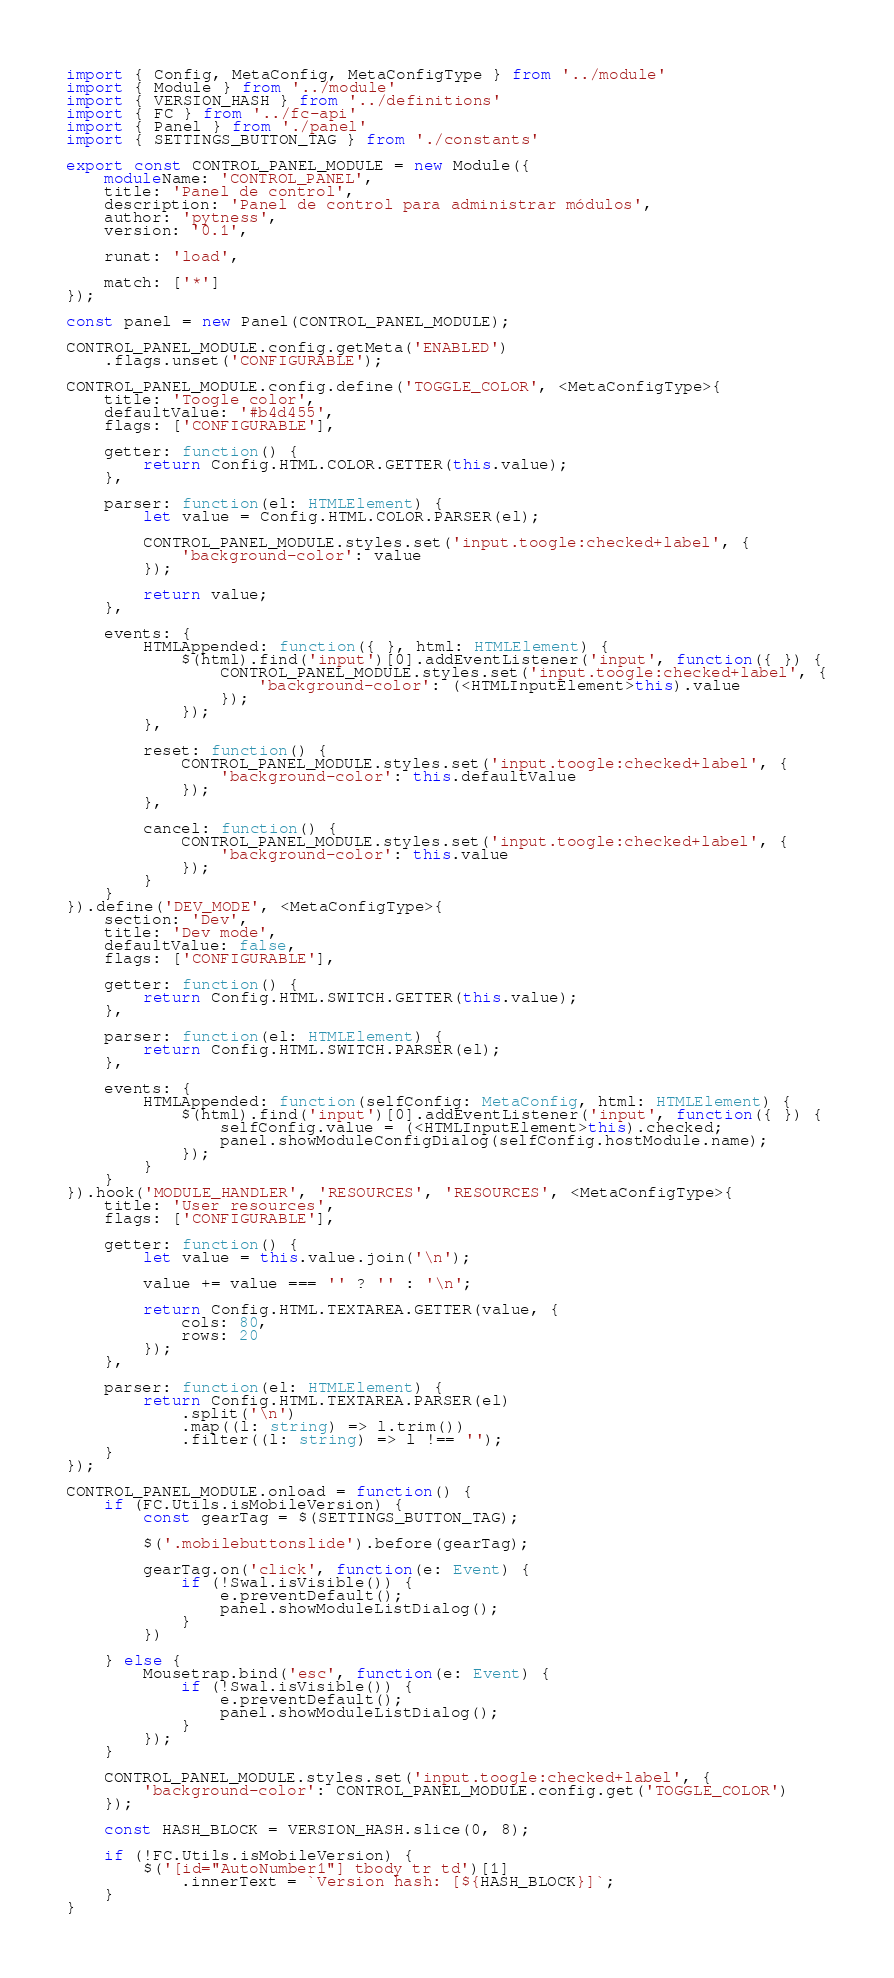Convert code to text. <code><loc_0><loc_0><loc_500><loc_500><_TypeScript_>import { Config, MetaConfig, MetaConfigType } from '../module'
import { Module } from '../module'
import { VERSION_HASH } from '../definitions'
import { FC } from '../fc-api'
import { Panel } from './panel'
import { SETTINGS_BUTTON_TAG } from './constants'

export const CONTROL_PANEL_MODULE = new Module({
	moduleName: 'CONTROL_PANEL',
	title: 'Panel de control',
	description: 'Panel de control para administrar módulos',
	author: 'pytness',
	version: '0.1',

	runat: 'load',

	match: ['*']
});

const panel = new Panel(CONTROL_PANEL_MODULE);

CONTROL_PANEL_MODULE.config.getMeta('ENABLED')
	.flags.unset('CONFIGURABLE');

CONTROL_PANEL_MODULE.config.define('TOGGLE_COLOR', <MetaConfigType>{
	title: 'Toogle color',
	defaultValue: '#b4d455',
	flags: ['CONFIGURABLE'],

	getter: function() {
		return Config.HTML.COLOR.GETTER(this.value);
	},

	parser: function(el: HTMLElement) {
		let value = Config.HTML.COLOR.PARSER(el);

		CONTROL_PANEL_MODULE.styles.set('input.toogle:checked+label', {
			'background-color': value
		});

		return value;
	},

	events: {
		HTMLAppended: function({ }, html: HTMLElement) {
			$(html).find('input')[0].addEventListener('input', function({ }) {
				CONTROL_PANEL_MODULE.styles.set('input.toogle:checked+label', {
					'background-color': (<HTMLInputElement>this).value
				});
			});
		},

		reset: function() {
			CONTROL_PANEL_MODULE.styles.set('input.toogle:checked+label', {
				'background-color': this.defaultValue
			});
		},

		cancel: function() {
			CONTROL_PANEL_MODULE.styles.set('input.toogle:checked+label', {
				'background-color': this.value
			});
		}
	}
}).define('DEV_MODE', <MetaConfigType>{
	section: 'Dev',
	title: 'Dev mode',
	defaultValue: false,
	flags: ['CONFIGURABLE'],

	getter: function() {
		return Config.HTML.SWITCH.GETTER(this.value);
	},

	parser: function(el: HTMLElement) {
		return Config.HTML.SWITCH.PARSER(el);
	},

	events: {
		HTMLAppended: function(selfConfig: MetaConfig, html: HTMLElement) {
			$(html).find('input')[0].addEventListener('input', function({ }) {
				selfConfig.value = (<HTMLInputElement>this).checked;
				panel.showModuleConfigDialog(selfConfig.hostModule.name);
			});
		}
	}
}).hook('MODULE_HANDLER', 'RESOURCES', 'RESOURCES', <MetaConfigType>{
	title: 'User resources',
	flags: ['CONFIGURABLE'],

	getter: function() {
		let value = this.value.join('\n');

		value += value === '' ? '' : '\n';

		return Config.HTML.TEXTAREA.GETTER(value, {
			cols: 80,
			rows: 20
		});
	},

	parser: function(el: HTMLElement) {
		return Config.HTML.TEXTAREA.PARSER(el)
			.split('\n')
			.map((l: string) => l.trim())
			.filter((l: string) => l !== '');
	}
});

CONTROL_PANEL_MODULE.onload = function() {
	if (FC.Utils.isMobileVersion) {
		const gearTag = $(SETTINGS_BUTTON_TAG);

		$('.mobilebuttonslide').before(gearTag);

		gearTag.on('click', function(e: Event) {
			if (!Swal.isVisible()) {
				e.preventDefault();
				panel.showModuleListDialog();
			}
		})

	} else {
		Mousetrap.bind('esc', function(e: Event) {
			if (!Swal.isVisible()) {
				e.preventDefault();
				panel.showModuleListDialog();
			}
		});
	}

	CONTROL_PANEL_MODULE.styles.set('input.toogle:checked+label', {
		'background-color': CONTROL_PANEL_MODULE.config.get('TOGGLE_COLOR')
	});

	const HASH_BLOCK = VERSION_HASH.slice(0, 8);

	if (!FC.Utils.isMobileVersion) {
		$('[id="AutoNumber1"] tbody tr td')[1]
			.innerText = `Version hash: [${HASH_BLOCK}]`;
	}
}
</code> 